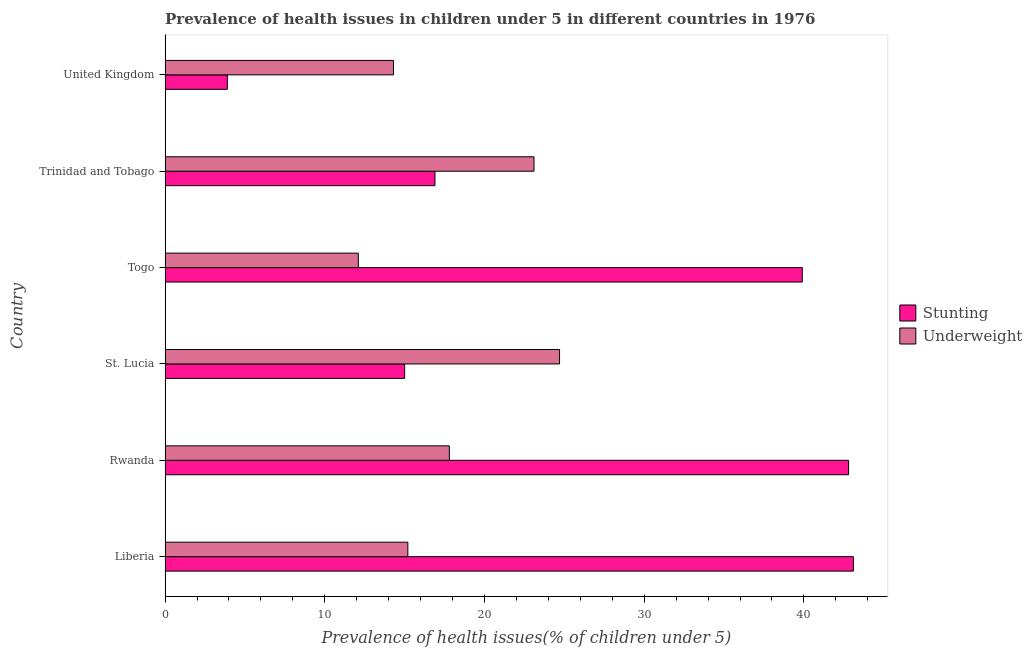How many different coloured bars are there?
Offer a very short reply. 2. What is the label of the 1st group of bars from the top?
Ensure brevity in your answer.  United Kingdom. In how many cases, is the number of bars for a given country not equal to the number of legend labels?
Your answer should be very brief. 0. What is the percentage of stunted children in Liberia?
Provide a succinct answer. 43.1. Across all countries, what is the maximum percentage of underweight children?
Provide a succinct answer. 24.7. Across all countries, what is the minimum percentage of underweight children?
Your response must be concise. 12.1. In which country was the percentage of underweight children maximum?
Provide a short and direct response. St. Lucia. In which country was the percentage of underweight children minimum?
Offer a terse response. Togo. What is the total percentage of stunted children in the graph?
Offer a very short reply. 161.6. What is the difference between the percentage of underweight children in United Kingdom and the percentage of stunted children in Rwanda?
Make the answer very short. -28.5. What is the average percentage of underweight children per country?
Provide a succinct answer. 17.87. What is the difference between the percentage of underweight children and percentage of stunted children in Liberia?
Ensure brevity in your answer.  -27.9. What is the ratio of the percentage of underweight children in Liberia to that in St. Lucia?
Your answer should be compact. 0.61. What is the difference between the highest and the lowest percentage of stunted children?
Your answer should be compact. 39.2. In how many countries, is the percentage of underweight children greater than the average percentage of underweight children taken over all countries?
Your answer should be very brief. 2. What does the 1st bar from the top in Liberia represents?
Offer a very short reply. Underweight. What does the 2nd bar from the bottom in Rwanda represents?
Provide a short and direct response. Underweight. How many countries are there in the graph?
Keep it short and to the point. 6. What is the difference between two consecutive major ticks on the X-axis?
Offer a terse response. 10. Are the values on the major ticks of X-axis written in scientific E-notation?
Keep it short and to the point. No. How are the legend labels stacked?
Keep it short and to the point. Vertical. What is the title of the graph?
Provide a short and direct response. Prevalence of health issues in children under 5 in different countries in 1976. What is the label or title of the X-axis?
Offer a very short reply. Prevalence of health issues(% of children under 5). What is the Prevalence of health issues(% of children under 5) in Stunting in Liberia?
Provide a short and direct response. 43.1. What is the Prevalence of health issues(% of children under 5) of Underweight in Liberia?
Make the answer very short. 15.2. What is the Prevalence of health issues(% of children under 5) of Stunting in Rwanda?
Ensure brevity in your answer.  42.8. What is the Prevalence of health issues(% of children under 5) in Underweight in Rwanda?
Ensure brevity in your answer.  17.8. What is the Prevalence of health issues(% of children under 5) in Underweight in St. Lucia?
Your answer should be very brief. 24.7. What is the Prevalence of health issues(% of children under 5) of Stunting in Togo?
Offer a very short reply. 39.9. What is the Prevalence of health issues(% of children under 5) in Underweight in Togo?
Offer a terse response. 12.1. What is the Prevalence of health issues(% of children under 5) in Stunting in Trinidad and Tobago?
Offer a very short reply. 16.9. What is the Prevalence of health issues(% of children under 5) of Underweight in Trinidad and Tobago?
Your response must be concise. 23.1. What is the Prevalence of health issues(% of children under 5) of Stunting in United Kingdom?
Offer a terse response. 3.9. What is the Prevalence of health issues(% of children under 5) of Underweight in United Kingdom?
Make the answer very short. 14.3. Across all countries, what is the maximum Prevalence of health issues(% of children under 5) in Stunting?
Give a very brief answer. 43.1. Across all countries, what is the maximum Prevalence of health issues(% of children under 5) of Underweight?
Your response must be concise. 24.7. Across all countries, what is the minimum Prevalence of health issues(% of children under 5) of Stunting?
Ensure brevity in your answer.  3.9. Across all countries, what is the minimum Prevalence of health issues(% of children under 5) of Underweight?
Provide a succinct answer. 12.1. What is the total Prevalence of health issues(% of children under 5) in Stunting in the graph?
Keep it short and to the point. 161.6. What is the total Prevalence of health issues(% of children under 5) in Underweight in the graph?
Provide a succinct answer. 107.2. What is the difference between the Prevalence of health issues(% of children under 5) of Stunting in Liberia and that in St. Lucia?
Keep it short and to the point. 28.1. What is the difference between the Prevalence of health issues(% of children under 5) in Underweight in Liberia and that in Togo?
Your answer should be compact. 3.1. What is the difference between the Prevalence of health issues(% of children under 5) in Stunting in Liberia and that in Trinidad and Tobago?
Offer a terse response. 26.2. What is the difference between the Prevalence of health issues(% of children under 5) in Underweight in Liberia and that in Trinidad and Tobago?
Make the answer very short. -7.9. What is the difference between the Prevalence of health issues(% of children under 5) in Stunting in Liberia and that in United Kingdom?
Your answer should be compact. 39.2. What is the difference between the Prevalence of health issues(% of children under 5) of Underweight in Liberia and that in United Kingdom?
Your answer should be compact. 0.9. What is the difference between the Prevalence of health issues(% of children under 5) in Stunting in Rwanda and that in St. Lucia?
Offer a very short reply. 27.8. What is the difference between the Prevalence of health issues(% of children under 5) of Underweight in Rwanda and that in St. Lucia?
Provide a succinct answer. -6.9. What is the difference between the Prevalence of health issues(% of children under 5) in Stunting in Rwanda and that in Togo?
Give a very brief answer. 2.9. What is the difference between the Prevalence of health issues(% of children under 5) in Underweight in Rwanda and that in Togo?
Offer a very short reply. 5.7. What is the difference between the Prevalence of health issues(% of children under 5) in Stunting in Rwanda and that in Trinidad and Tobago?
Ensure brevity in your answer.  25.9. What is the difference between the Prevalence of health issues(% of children under 5) of Underweight in Rwanda and that in Trinidad and Tobago?
Offer a terse response. -5.3. What is the difference between the Prevalence of health issues(% of children under 5) of Stunting in Rwanda and that in United Kingdom?
Your answer should be compact. 38.9. What is the difference between the Prevalence of health issues(% of children under 5) of Stunting in St. Lucia and that in Togo?
Keep it short and to the point. -24.9. What is the difference between the Prevalence of health issues(% of children under 5) in Underweight in Togo and that in Trinidad and Tobago?
Your answer should be compact. -11. What is the difference between the Prevalence of health issues(% of children under 5) in Stunting in Togo and that in United Kingdom?
Give a very brief answer. 36. What is the difference between the Prevalence of health issues(% of children under 5) in Stunting in Liberia and the Prevalence of health issues(% of children under 5) in Underweight in Rwanda?
Provide a short and direct response. 25.3. What is the difference between the Prevalence of health issues(% of children under 5) in Stunting in Liberia and the Prevalence of health issues(% of children under 5) in Underweight in Togo?
Your answer should be compact. 31. What is the difference between the Prevalence of health issues(% of children under 5) in Stunting in Liberia and the Prevalence of health issues(% of children under 5) in Underweight in United Kingdom?
Your answer should be very brief. 28.8. What is the difference between the Prevalence of health issues(% of children under 5) of Stunting in Rwanda and the Prevalence of health issues(% of children under 5) of Underweight in St. Lucia?
Offer a very short reply. 18.1. What is the difference between the Prevalence of health issues(% of children under 5) of Stunting in Rwanda and the Prevalence of health issues(% of children under 5) of Underweight in Togo?
Provide a short and direct response. 30.7. What is the difference between the Prevalence of health issues(% of children under 5) of Stunting in Togo and the Prevalence of health issues(% of children under 5) of Underweight in United Kingdom?
Provide a short and direct response. 25.6. What is the difference between the Prevalence of health issues(% of children under 5) of Stunting in Trinidad and Tobago and the Prevalence of health issues(% of children under 5) of Underweight in United Kingdom?
Make the answer very short. 2.6. What is the average Prevalence of health issues(% of children under 5) of Stunting per country?
Your answer should be very brief. 26.93. What is the average Prevalence of health issues(% of children under 5) in Underweight per country?
Make the answer very short. 17.87. What is the difference between the Prevalence of health issues(% of children under 5) of Stunting and Prevalence of health issues(% of children under 5) of Underweight in Liberia?
Your response must be concise. 27.9. What is the difference between the Prevalence of health issues(% of children under 5) of Stunting and Prevalence of health issues(% of children under 5) of Underweight in St. Lucia?
Your response must be concise. -9.7. What is the difference between the Prevalence of health issues(% of children under 5) in Stunting and Prevalence of health issues(% of children under 5) in Underweight in Togo?
Keep it short and to the point. 27.8. What is the difference between the Prevalence of health issues(% of children under 5) of Stunting and Prevalence of health issues(% of children under 5) of Underweight in Trinidad and Tobago?
Your answer should be very brief. -6.2. What is the difference between the Prevalence of health issues(% of children under 5) of Stunting and Prevalence of health issues(% of children under 5) of Underweight in United Kingdom?
Your answer should be compact. -10.4. What is the ratio of the Prevalence of health issues(% of children under 5) of Stunting in Liberia to that in Rwanda?
Provide a short and direct response. 1.01. What is the ratio of the Prevalence of health issues(% of children under 5) of Underweight in Liberia to that in Rwanda?
Ensure brevity in your answer.  0.85. What is the ratio of the Prevalence of health issues(% of children under 5) in Stunting in Liberia to that in St. Lucia?
Offer a very short reply. 2.87. What is the ratio of the Prevalence of health issues(% of children under 5) of Underweight in Liberia to that in St. Lucia?
Ensure brevity in your answer.  0.62. What is the ratio of the Prevalence of health issues(% of children under 5) in Stunting in Liberia to that in Togo?
Your answer should be very brief. 1.08. What is the ratio of the Prevalence of health issues(% of children under 5) in Underweight in Liberia to that in Togo?
Make the answer very short. 1.26. What is the ratio of the Prevalence of health issues(% of children under 5) in Stunting in Liberia to that in Trinidad and Tobago?
Keep it short and to the point. 2.55. What is the ratio of the Prevalence of health issues(% of children under 5) in Underweight in Liberia to that in Trinidad and Tobago?
Your answer should be very brief. 0.66. What is the ratio of the Prevalence of health issues(% of children under 5) in Stunting in Liberia to that in United Kingdom?
Provide a short and direct response. 11.05. What is the ratio of the Prevalence of health issues(% of children under 5) in Underweight in Liberia to that in United Kingdom?
Offer a very short reply. 1.06. What is the ratio of the Prevalence of health issues(% of children under 5) in Stunting in Rwanda to that in St. Lucia?
Your answer should be compact. 2.85. What is the ratio of the Prevalence of health issues(% of children under 5) of Underweight in Rwanda to that in St. Lucia?
Provide a succinct answer. 0.72. What is the ratio of the Prevalence of health issues(% of children under 5) of Stunting in Rwanda to that in Togo?
Ensure brevity in your answer.  1.07. What is the ratio of the Prevalence of health issues(% of children under 5) of Underweight in Rwanda to that in Togo?
Make the answer very short. 1.47. What is the ratio of the Prevalence of health issues(% of children under 5) in Stunting in Rwanda to that in Trinidad and Tobago?
Make the answer very short. 2.53. What is the ratio of the Prevalence of health issues(% of children under 5) in Underweight in Rwanda to that in Trinidad and Tobago?
Offer a very short reply. 0.77. What is the ratio of the Prevalence of health issues(% of children under 5) in Stunting in Rwanda to that in United Kingdom?
Your answer should be very brief. 10.97. What is the ratio of the Prevalence of health issues(% of children under 5) of Underweight in Rwanda to that in United Kingdom?
Keep it short and to the point. 1.24. What is the ratio of the Prevalence of health issues(% of children under 5) of Stunting in St. Lucia to that in Togo?
Provide a short and direct response. 0.38. What is the ratio of the Prevalence of health issues(% of children under 5) of Underweight in St. Lucia to that in Togo?
Your answer should be compact. 2.04. What is the ratio of the Prevalence of health issues(% of children under 5) in Stunting in St. Lucia to that in Trinidad and Tobago?
Provide a short and direct response. 0.89. What is the ratio of the Prevalence of health issues(% of children under 5) in Underweight in St. Lucia to that in Trinidad and Tobago?
Your answer should be compact. 1.07. What is the ratio of the Prevalence of health issues(% of children under 5) in Stunting in St. Lucia to that in United Kingdom?
Provide a short and direct response. 3.85. What is the ratio of the Prevalence of health issues(% of children under 5) of Underweight in St. Lucia to that in United Kingdom?
Offer a very short reply. 1.73. What is the ratio of the Prevalence of health issues(% of children under 5) of Stunting in Togo to that in Trinidad and Tobago?
Your answer should be very brief. 2.36. What is the ratio of the Prevalence of health issues(% of children under 5) in Underweight in Togo to that in Trinidad and Tobago?
Give a very brief answer. 0.52. What is the ratio of the Prevalence of health issues(% of children under 5) of Stunting in Togo to that in United Kingdom?
Give a very brief answer. 10.23. What is the ratio of the Prevalence of health issues(% of children under 5) of Underweight in Togo to that in United Kingdom?
Provide a succinct answer. 0.85. What is the ratio of the Prevalence of health issues(% of children under 5) of Stunting in Trinidad and Tobago to that in United Kingdom?
Provide a short and direct response. 4.33. What is the ratio of the Prevalence of health issues(% of children under 5) in Underweight in Trinidad and Tobago to that in United Kingdom?
Your answer should be compact. 1.62. What is the difference between the highest and the lowest Prevalence of health issues(% of children under 5) in Stunting?
Your response must be concise. 39.2. 